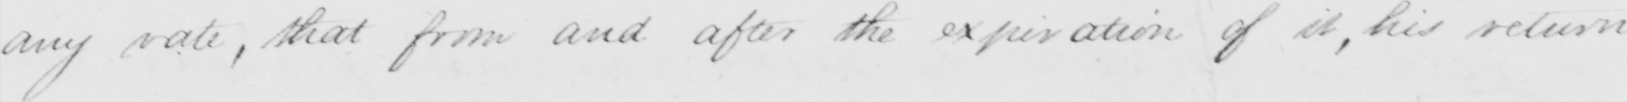What text is written in this handwritten line? any rate, that from and after the expiration of it, his return 